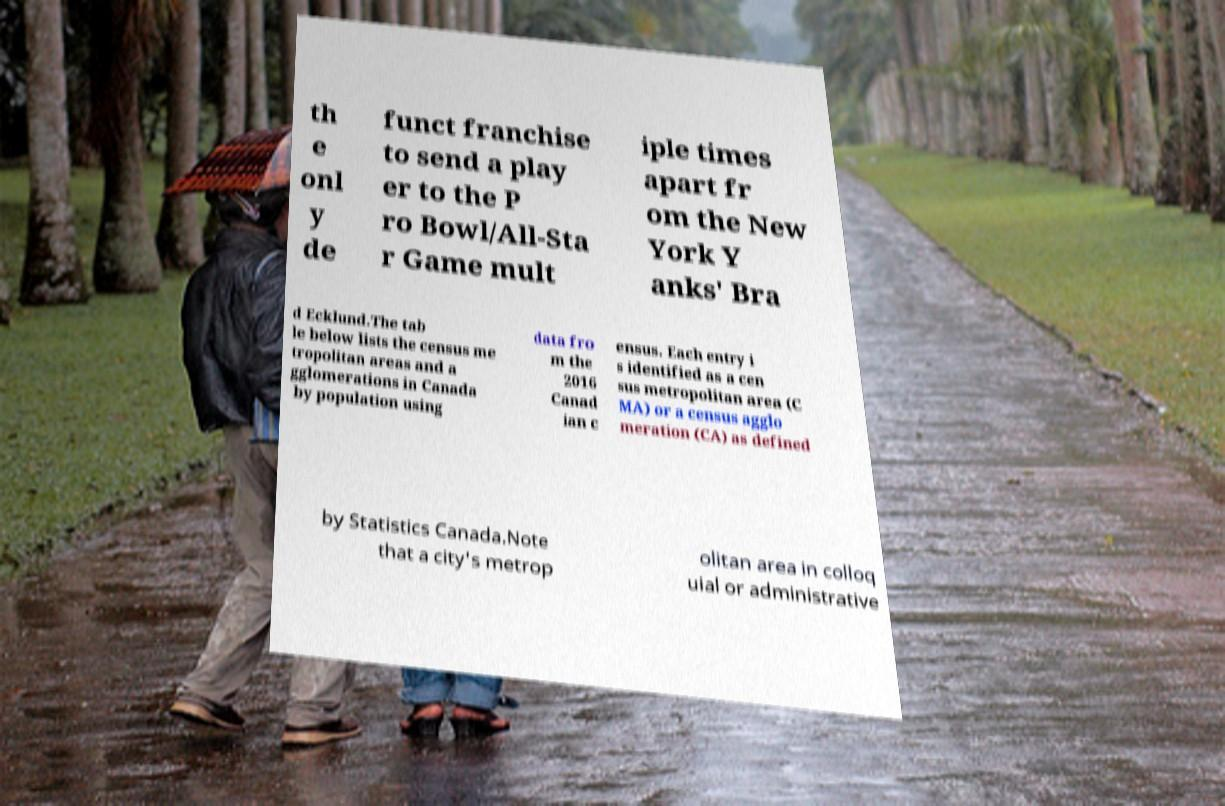I need the written content from this picture converted into text. Can you do that? th e onl y de funct franchise to send a play er to the P ro Bowl/All-Sta r Game mult iple times apart fr om the New York Y anks' Bra d Ecklund.The tab le below lists the census me tropolitan areas and a gglomerations in Canada by population using data fro m the 2016 Canad ian c ensus. Each entry i s identified as a cen sus metropolitan area (C MA) or a census agglo meration (CA) as defined by Statistics Canada.Note that a city's metrop olitan area in colloq uial or administrative 